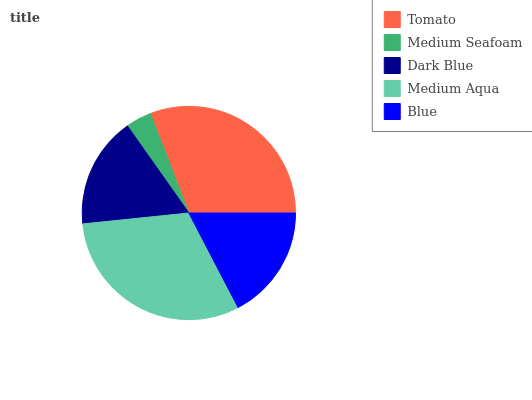Is Medium Seafoam the minimum?
Answer yes or no. Yes. Is Medium Aqua the maximum?
Answer yes or no. Yes. Is Dark Blue the minimum?
Answer yes or no. No. Is Dark Blue the maximum?
Answer yes or no. No. Is Dark Blue greater than Medium Seafoam?
Answer yes or no. Yes. Is Medium Seafoam less than Dark Blue?
Answer yes or no. Yes. Is Medium Seafoam greater than Dark Blue?
Answer yes or no. No. Is Dark Blue less than Medium Seafoam?
Answer yes or no. No. Is Blue the high median?
Answer yes or no. Yes. Is Blue the low median?
Answer yes or no. Yes. Is Medium Seafoam the high median?
Answer yes or no. No. Is Tomato the low median?
Answer yes or no. No. 